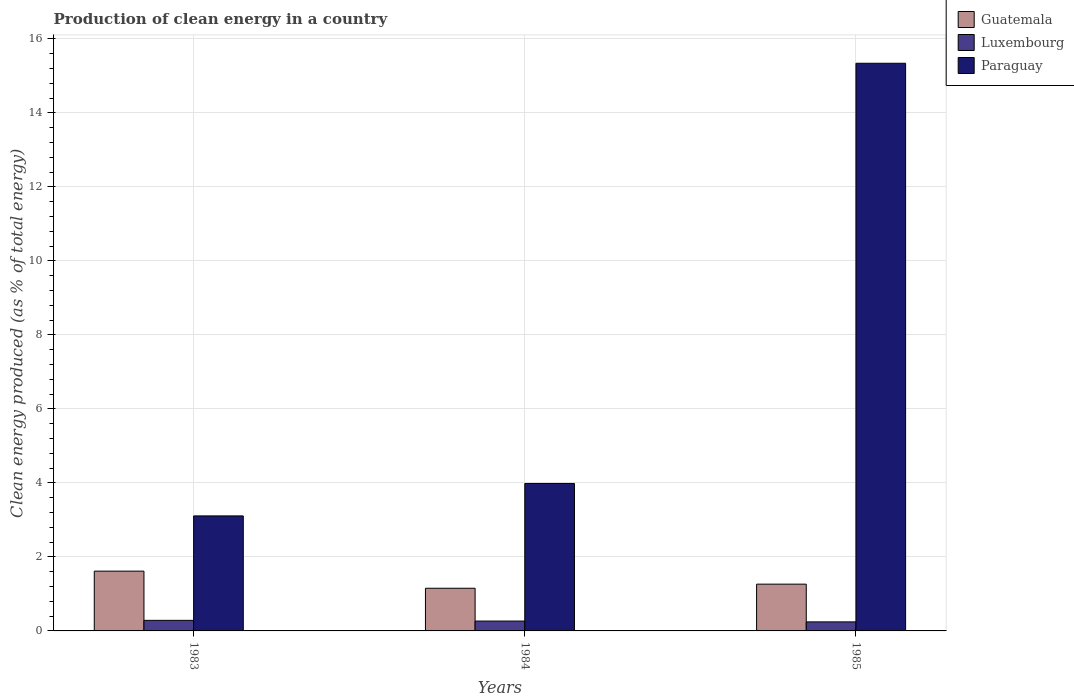How many different coloured bars are there?
Make the answer very short. 3. How many groups of bars are there?
Your answer should be very brief. 3. Are the number of bars on each tick of the X-axis equal?
Provide a succinct answer. Yes. How many bars are there on the 3rd tick from the left?
Ensure brevity in your answer.  3. How many bars are there on the 2nd tick from the right?
Ensure brevity in your answer.  3. What is the label of the 1st group of bars from the left?
Your answer should be compact. 1983. In how many cases, is the number of bars for a given year not equal to the number of legend labels?
Provide a short and direct response. 0. What is the percentage of clean energy produced in Luxembourg in 1984?
Ensure brevity in your answer.  0.27. Across all years, what is the maximum percentage of clean energy produced in Guatemala?
Provide a short and direct response. 1.62. Across all years, what is the minimum percentage of clean energy produced in Guatemala?
Make the answer very short. 1.15. What is the total percentage of clean energy produced in Paraguay in the graph?
Your response must be concise. 22.43. What is the difference between the percentage of clean energy produced in Guatemala in 1983 and that in 1985?
Provide a short and direct response. 0.35. What is the difference between the percentage of clean energy produced in Luxembourg in 1985 and the percentage of clean energy produced in Guatemala in 1984?
Your response must be concise. -0.91. What is the average percentage of clean energy produced in Luxembourg per year?
Your answer should be compact. 0.27. In the year 1983, what is the difference between the percentage of clean energy produced in Guatemala and percentage of clean energy produced in Luxembourg?
Your answer should be compact. 1.33. In how many years, is the percentage of clean energy produced in Luxembourg greater than 5.2 %?
Your response must be concise. 0. What is the ratio of the percentage of clean energy produced in Guatemala in 1984 to that in 1985?
Your answer should be very brief. 0.91. Is the percentage of clean energy produced in Luxembourg in 1983 less than that in 1984?
Make the answer very short. No. What is the difference between the highest and the second highest percentage of clean energy produced in Guatemala?
Offer a terse response. 0.35. What is the difference between the highest and the lowest percentage of clean energy produced in Paraguay?
Your answer should be compact. 12.23. In how many years, is the percentage of clean energy produced in Guatemala greater than the average percentage of clean energy produced in Guatemala taken over all years?
Provide a succinct answer. 1. What does the 3rd bar from the left in 1983 represents?
Keep it short and to the point. Paraguay. What does the 2nd bar from the right in 1984 represents?
Make the answer very short. Luxembourg. Is it the case that in every year, the sum of the percentage of clean energy produced in Paraguay and percentage of clean energy produced in Luxembourg is greater than the percentage of clean energy produced in Guatemala?
Provide a short and direct response. Yes. Are all the bars in the graph horizontal?
Your answer should be compact. No. Are the values on the major ticks of Y-axis written in scientific E-notation?
Your answer should be very brief. No. Does the graph contain grids?
Ensure brevity in your answer.  Yes. Where does the legend appear in the graph?
Give a very brief answer. Top right. What is the title of the graph?
Your answer should be compact. Production of clean energy in a country. Does "United Arab Emirates" appear as one of the legend labels in the graph?
Provide a short and direct response. No. What is the label or title of the X-axis?
Your answer should be compact. Years. What is the label or title of the Y-axis?
Offer a very short reply. Clean energy produced (as % of total energy). What is the Clean energy produced (as % of total energy) of Guatemala in 1983?
Your answer should be very brief. 1.62. What is the Clean energy produced (as % of total energy) of Luxembourg in 1983?
Offer a very short reply. 0.29. What is the Clean energy produced (as % of total energy) in Paraguay in 1983?
Offer a very short reply. 3.11. What is the Clean energy produced (as % of total energy) in Guatemala in 1984?
Your answer should be very brief. 1.15. What is the Clean energy produced (as % of total energy) of Luxembourg in 1984?
Provide a short and direct response. 0.27. What is the Clean energy produced (as % of total energy) in Paraguay in 1984?
Provide a short and direct response. 3.98. What is the Clean energy produced (as % of total energy) of Guatemala in 1985?
Give a very brief answer. 1.26. What is the Clean energy produced (as % of total energy) in Luxembourg in 1985?
Your response must be concise. 0.24. What is the Clean energy produced (as % of total energy) of Paraguay in 1985?
Make the answer very short. 15.34. Across all years, what is the maximum Clean energy produced (as % of total energy) of Guatemala?
Your answer should be very brief. 1.62. Across all years, what is the maximum Clean energy produced (as % of total energy) of Luxembourg?
Provide a succinct answer. 0.29. Across all years, what is the maximum Clean energy produced (as % of total energy) of Paraguay?
Provide a succinct answer. 15.34. Across all years, what is the minimum Clean energy produced (as % of total energy) in Guatemala?
Provide a short and direct response. 1.15. Across all years, what is the minimum Clean energy produced (as % of total energy) in Luxembourg?
Your response must be concise. 0.24. Across all years, what is the minimum Clean energy produced (as % of total energy) in Paraguay?
Make the answer very short. 3.11. What is the total Clean energy produced (as % of total energy) in Guatemala in the graph?
Keep it short and to the point. 4.03. What is the total Clean energy produced (as % of total energy) of Luxembourg in the graph?
Your response must be concise. 0.8. What is the total Clean energy produced (as % of total energy) in Paraguay in the graph?
Provide a succinct answer. 22.43. What is the difference between the Clean energy produced (as % of total energy) of Guatemala in 1983 and that in 1984?
Give a very brief answer. 0.46. What is the difference between the Clean energy produced (as % of total energy) of Luxembourg in 1983 and that in 1984?
Provide a succinct answer. 0.02. What is the difference between the Clean energy produced (as % of total energy) of Paraguay in 1983 and that in 1984?
Your answer should be very brief. -0.88. What is the difference between the Clean energy produced (as % of total energy) in Guatemala in 1983 and that in 1985?
Offer a terse response. 0.35. What is the difference between the Clean energy produced (as % of total energy) in Luxembourg in 1983 and that in 1985?
Your answer should be compact. 0.04. What is the difference between the Clean energy produced (as % of total energy) in Paraguay in 1983 and that in 1985?
Your answer should be very brief. -12.23. What is the difference between the Clean energy produced (as % of total energy) of Guatemala in 1984 and that in 1985?
Offer a very short reply. -0.11. What is the difference between the Clean energy produced (as % of total energy) of Luxembourg in 1984 and that in 1985?
Offer a very short reply. 0.02. What is the difference between the Clean energy produced (as % of total energy) in Paraguay in 1984 and that in 1985?
Make the answer very short. -11.36. What is the difference between the Clean energy produced (as % of total energy) of Guatemala in 1983 and the Clean energy produced (as % of total energy) of Luxembourg in 1984?
Offer a terse response. 1.35. What is the difference between the Clean energy produced (as % of total energy) of Guatemala in 1983 and the Clean energy produced (as % of total energy) of Paraguay in 1984?
Provide a succinct answer. -2.37. What is the difference between the Clean energy produced (as % of total energy) of Luxembourg in 1983 and the Clean energy produced (as % of total energy) of Paraguay in 1984?
Make the answer very short. -3.7. What is the difference between the Clean energy produced (as % of total energy) of Guatemala in 1983 and the Clean energy produced (as % of total energy) of Luxembourg in 1985?
Provide a short and direct response. 1.37. What is the difference between the Clean energy produced (as % of total energy) in Guatemala in 1983 and the Clean energy produced (as % of total energy) in Paraguay in 1985?
Your answer should be very brief. -13.72. What is the difference between the Clean energy produced (as % of total energy) in Luxembourg in 1983 and the Clean energy produced (as % of total energy) in Paraguay in 1985?
Your response must be concise. -15.05. What is the difference between the Clean energy produced (as % of total energy) in Guatemala in 1984 and the Clean energy produced (as % of total energy) in Luxembourg in 1985?
Make the answer very short. 0.91. What is the difference between the Clean energy produced (as % of total energy) of Guatemala in 1984 and the Clean energy produced (as % of total energy) of Paraguay in 1985?
Your answer should be very brief. -14.19. What is the difference between the Clean energy produced (as % of total energy) in Luxembourg in 1984 and the Clean energy produced (as % of total energy) in Paraguay in 1985?
Keep it short and to the point. -15.07. What is the average Clean energy produced (as % of total energy) in Guatemala per year?
Your answer should be very brief. 1.34. What is the average Clean energy produced (as % of total energy) in Luxembourg per year?
Your answer should be compact. 0.27. What is the average Clean energy produced (as % of total energy) of Paraguay per year?
Your answer should be very brief. 7.48. In the year 1983, what is the difference between the Clean energy produced (as % of total energy) in Guatemala and Clean energy produced (as % of total energy) in Luxembourg?
Provide a succinct answer. 1.33. In the year 1983, what is the difference between the Clean energy produced (as % of total energy) in Guatemala and Clean energy produced (as % of total energy) in Paraguay?
Keep it short and to the point. -1.49. In the year 1983, what is the difference between the Clean energy produced (as % of total energy) of Luxembourg and Clean energy produced (as % of total energy) of Paraguay?
Offer a terse response. -2.82. In the year 1984, what is the difference between the Clean energy produced (as % of total energy) in Guatemala and Clean energy produced (as % of total energy) in Luxembourg?
Keep it short and to the point. 0.89. In the year 1984, what is the difference between the Clean energy produced (as % of total energy) in Guatemala and Clean energy produced (as % of total energy) in Paraguay?
Provide a short and direct response. -2.83. In the year 1984, what is the difference between the Clean energy produced (as % of total energy) of Luxembourg and Clean energy produced (as % of total energy) of Paraguay?
Ensure brevity in your answer.  -3.72. In the year 1985, what is the difference between the Clean energy produced (as % of total energy) in Guatemala and Clean energy produced (as % of total energy) in Luxembourg?
Your response must be concise. 1.02. In the year 1985, what is the difference between the Clean energy produced (as % of total energy) of Guatemala and Clean energy produced (as % of total energy) of Paraguay?
Your answer should be very brief. -14.08. In the year 1985, what is the difference between the Clean energy produced (as % of total energy) of Luxembourg and Clean energy produced (as % of total energy) of Paraguay?
Make the answer very short. -15.1. What is the ratio of the Clean energy produced (as % of total energy) of Guatemala in 1983 to that in 1984?
Offer a very short reply. 1.4. What is the ratio of the Clean energy produced (as % of total energy) in Luxembourg in 1983 to that in 1984?
Your answer should be compact. 1.07. What is the ratio of the Clean energy produced (as % of total energy) in Paraguay in 1983 to that in 1984?
Make the answer very short. 0.78. What is the ratio of the Clean energy produced (as % of total energy) in Guatemala in 1983 to that in 1985?
Make the answer very short. 1.28. What is the ratio of the Clean energy produced (as % of total energy) of Luxembourg in 1983 to that in 1985?
Offer a very short reply. 1.17. What is the ratio of the Clean energy produced (as % of total energy) of Paraguay in 1983 to that in 1985?
Your response must be concise. 0.2. What is the ratio of the Clean energy produced (as % of total energy) in Guatemala in 1984 to that in 1985?
Ensure brevity in your answer.  0.91. What is the ratio of the Clean energy produced (as % of total energy) in Luxembourg in 1984 to that in 1985?
Provide a short and direct response. 1.09. What is the ratio of the Clean energy produced (as % of total energy) in Paraguay in 1984 to that in 1985?
Your answer should be compact. 0.26. What is the difference between the highest and the second highest Clean energy produced (as % of total energy) of Guatemala?
Your answer should be compact. 0.35. What is the difference between the highest and the second highest Clean energy produced (as % of total energy) in Luxembourg?
Make the answer very short. 0.02. What is the difference between the highest and the second highest Clean energy produced (as % of total energy) of Paraguay?
Give a very brief answer. 11.36. What is the difference between the highest and the lowest Clean energy produced (as % of total energy) of Guatemala?
Your response must be concise. 0.46. What is the difference between the highest and the lowest Clean energy produced (as % of total energy) of Luxembourg?
Keep it short and to the point. 0.04. What is the difference between the highest and the lowest Clean energy produced (as % of total energy) in Paraguay?
Ensure brevity in your answer.  12.23. 